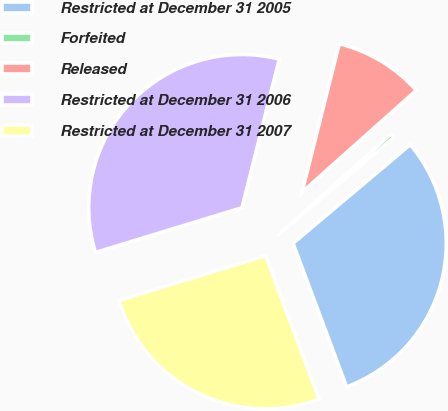<chart> <loc_0><loc_0><loc_500><loc_500><pie_chart><fcel>Restricted at December 31 2005<fcel>Forfeited<fcel>Released<fcel>Restricted at December 31 2006<fcel>Restricted at December 31 2007<nl><fcel>30.45%<fcel>0.46%<fcel>9.49%<fcel>33.63%<fcel>25.97%<nl></chart> 